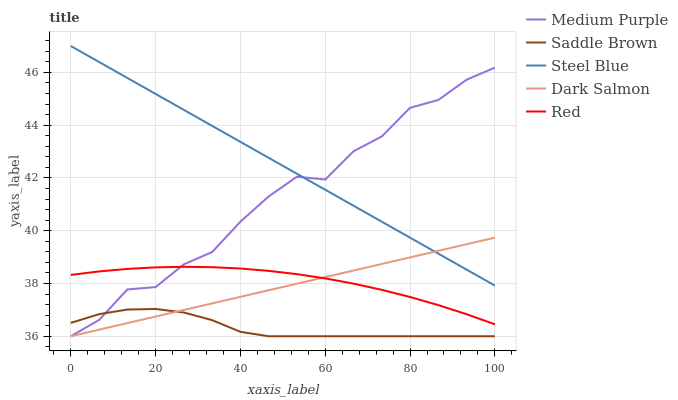Does Saddle Brown have the minimum area under the curve?
Answer yes or no. Yes. Does Steel Blue have the maximum area under the curve?
Answer yes or no. Yes. Does Dark Salmon have the minimum area under the curve?
Answer yes or no. No. Does Dark Salmon have the maximum area under the curve?
Answer yes or no. No. Is Dark Salmon the smoothest?
Answer yes or no. Yes. Is Medium Purple the roughest?
Answer yes or no. Yes. Is Saddle Brown the smoothest?
Answer yes or no. No. Is Saddle Brown the roughest?
Answer yes or no. No. Does Medium Purple have the lowest value?
Answer yes or no. Yes. Does Red have the lowest value?
Answer yes or no. No. Does Steel Blue have the highest value?
Answer yes or no. Yes. Does Dark Salmon have the highest value?
Answer yes or no. No. Is Saddle Brown less than Red?
Answer yes or no. Yes. Is Steel Blue greater than Red?
Answer yes or no. Yes. Does Medium Purple intersect Red?
Answer yes or no. Yes. Is Medium Purple less than Red?
Answer yes or no. No. Is Medium Purple greater than Red?
Answer yes or no. No. Does Saddle Brown intersect Red?
Answer yes or no. No. 